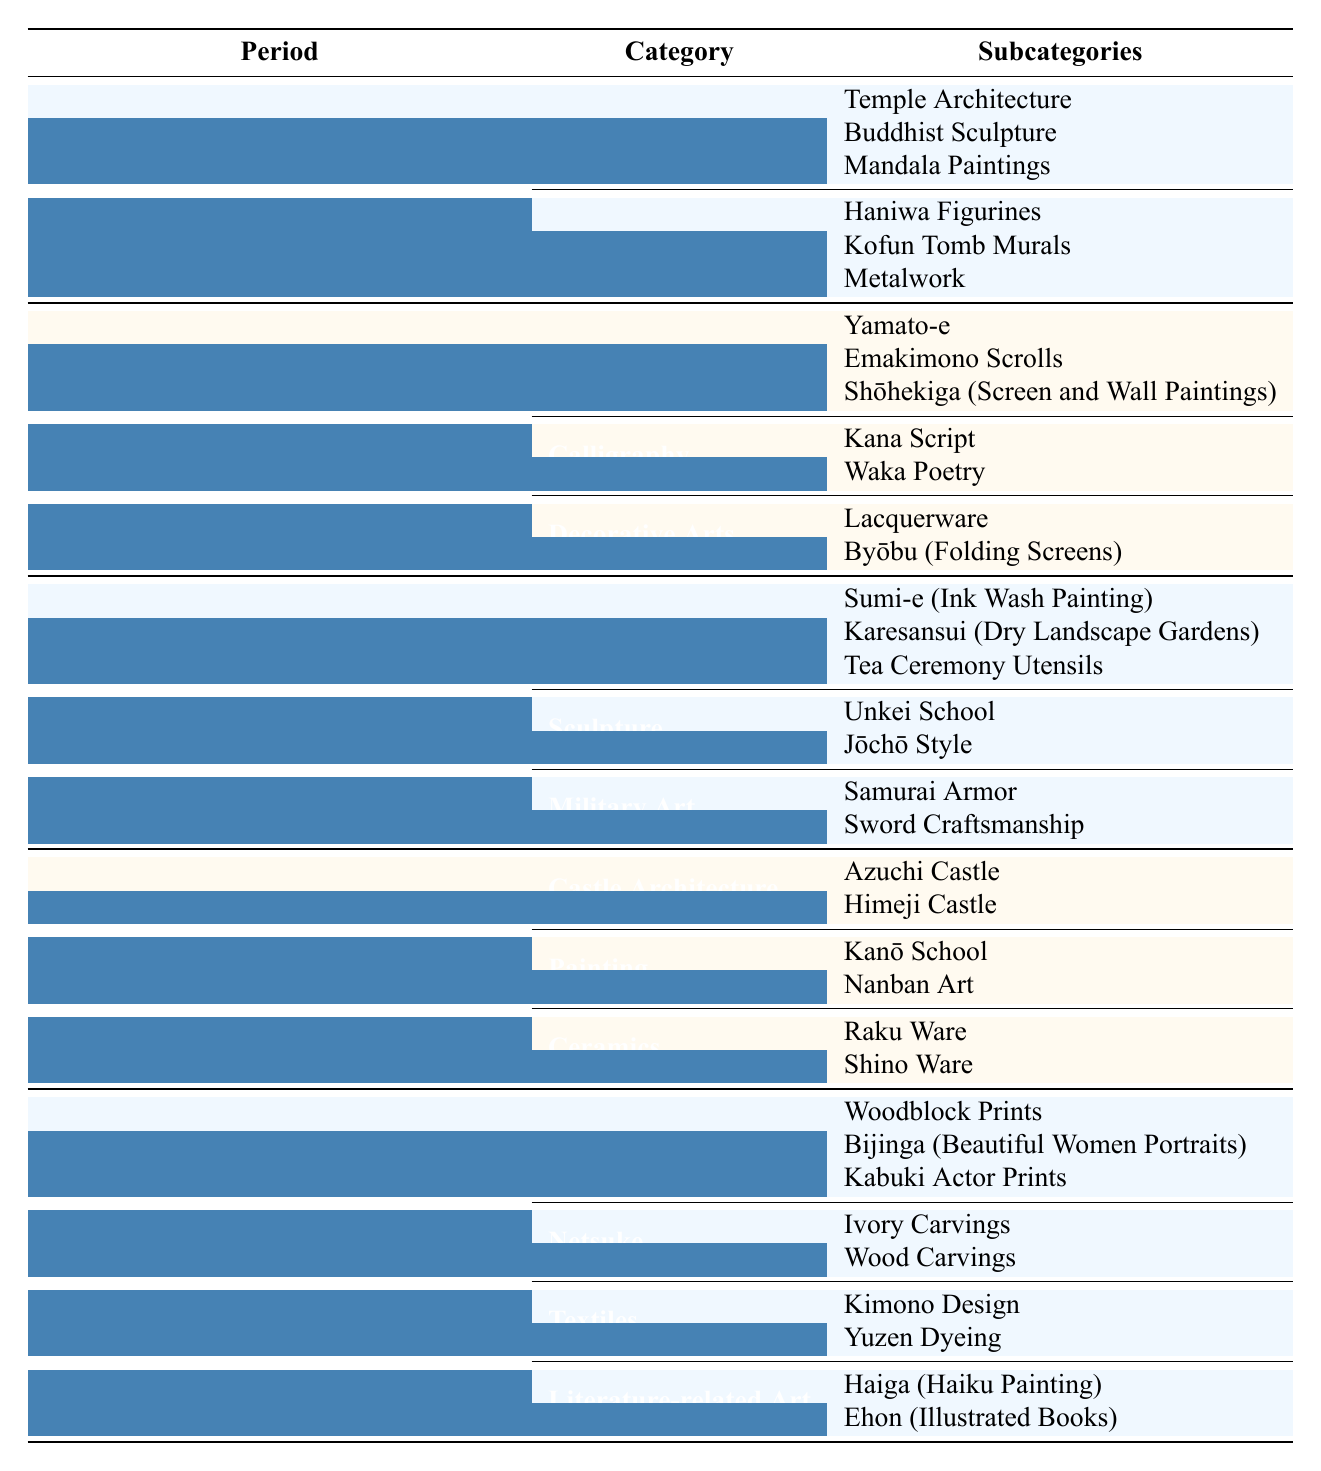What are the main categories of art in the Edo period? The Edo period has four main categories of art listed in the table: Ukiyo-e, Netsuke, Textiles, and Literature-related Art.
Answer: Ukiyo-e, Netsuke, Textiles, Literature-related Art Which period features Zen-influenced art forms? The Kamakura and Muromachi period (1185-1573) features Zen-influenced art forms, as indicated in the table.
Answer: Kamakura and Muromachi (1185-1573) How many subcategories are there under Buddhist Art in the Asuka and Nara period? Under Buddhist Art in the Asuka and Nara period, there are three subcategories: Temple Architecture, Buddhist Sculpture, and Mandala Paintings.
Answer: 3 Is Kanō School associated with the Azuchi-Momoyama period? Yes, the Kanō School is listed as a painting category under the Azuchi-Momoyama period.
Answer: Yes What is the total number of subcategories for art forms listed in the Edo period? The Edo period lists a total of 10 subcategories: 3 under Ukiyo-e, 2 under Netsuke, 2 under Textiles, and 2 under Literature-related Art. Therefore, the total is 3 + 2 + 2 + 2 = 9.
Answer: 9 In which period did Samurai Armor become an art form? Samurai Armor is categorized under Military Art in the Kamakura and Muromachi period (1185-1573).
Answer: Kamakura and Muromachi (1185-1573) Which art form includes Haiga? Haiga is included as a subcategory under the Literature-related Art category in the Edo period.
Answer: Literature-related Art How does the number of subcategories in the Heian period compare to the number in the Azuchi-Momoyama period? The Heian period has 7 subcategories (3 in Painting, 2 in Calligraphy, 2 in Decorative Arts) while the Azuchi-Momoyama period has 6 subcategories (2 in Castle Architecture, 2 in Painting, 2 in Ceramics). Therefore, Heian has more subcategories than Azuchi-Momoyama.
Answer: Heian has more What is the difference in the number of subcategories between the Asuka and Nara period and the Edo period? The Asuka and Nara period has 6 subcategories (3 in Buddhist Art, 3 in Secular Art), while the Edo period has 9 subcategories, leading to a difference of 9 - 6 = 3.
Answer: 3 List all the subcategories under Decorative Arts from the Heian period. The subcategories under Decorative Arts from the Heian period are Lacquerware and Byōbu (Folding Screens).
Answer: Lacquerware, Byōbu (Folding Screens) 